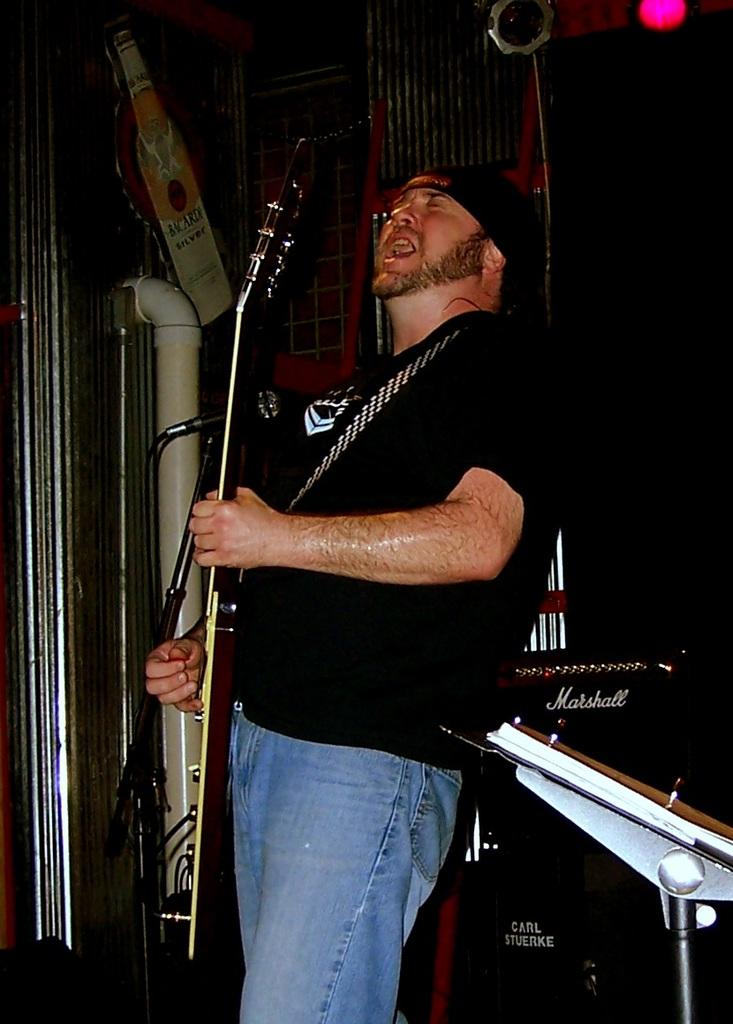Who is the main subject in the image? There is a man in the image. What is the man doing in the image? The man is performing in the image. What instrument is the man playing? The man is playing a guitar in the image. How is the man's voice being amplified in the image? The man is using a microphone in the image. Can you see a toad playing the guitar in the image? No, there is no toad present in the image, and the man is the one playing the guitar. 